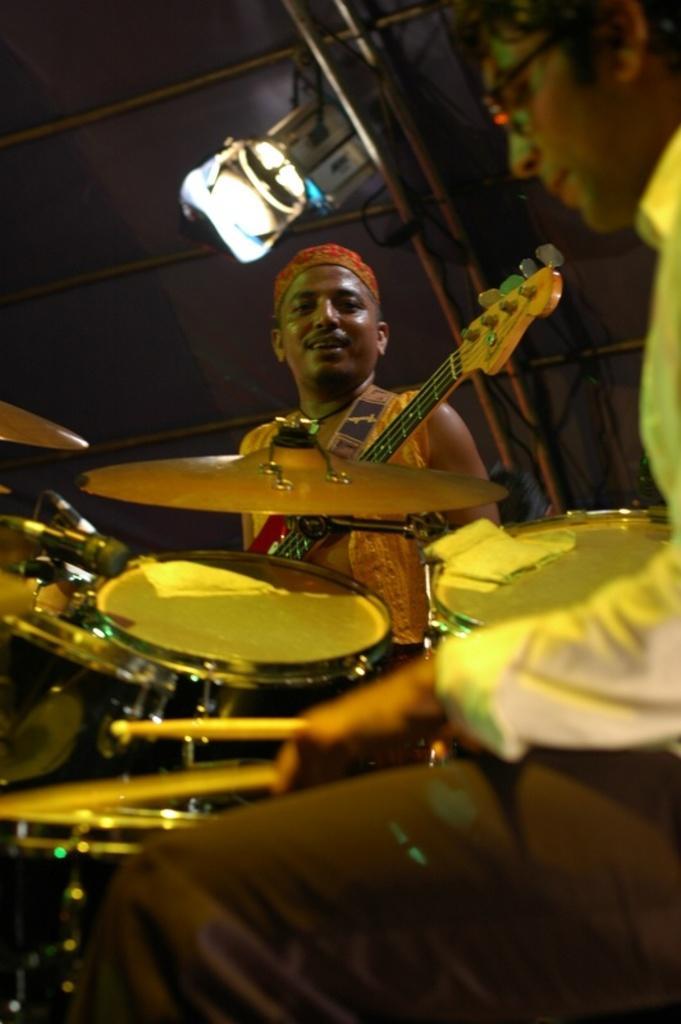In one or two sentences, can you explain what this image depicts? In the center of the image there is a man standing and holding a guitar. On the right there is another man who is playing a band. At the top there is a light which is attached to the tent. 